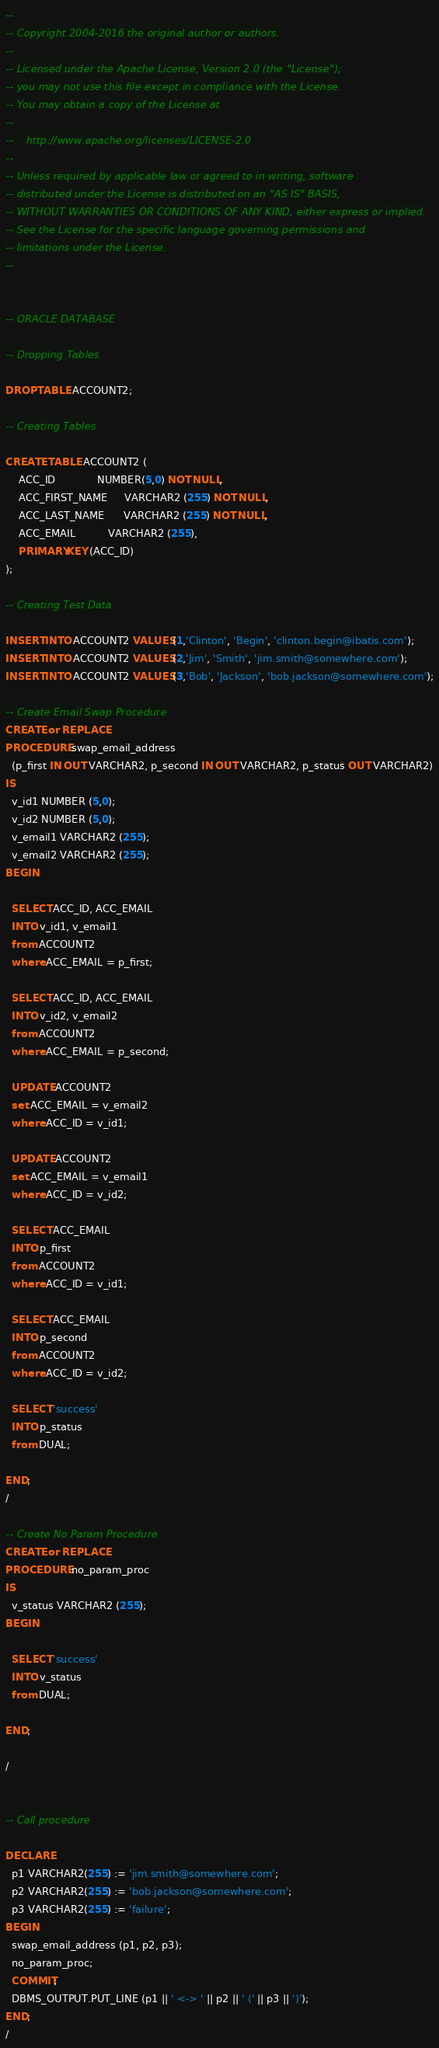<code> <loc_0><loc_0><loc_500><loc_500><_SQL_>--
-- Copyright 2004-2016 the original author or authors.
--
-- Licensed under the Apache License, Version 2.0 (the "License");
-- you may not use this file except in compliance with the License.
-- You may obtain a copy of the License at
--
--    http://www.apache.org/licenses/LICENSE-2.0
--
-- Unless required by applicable law or agreed to in writing, software
-- distributed under the License is distributed on an "AS IS" BASIS,
-- WITHOUT WARRANTIES OR CONDITIONS OF ANY KIND, either express or implied.
-- See the License for the specific language governing permissions and
-- limitations under the License.
--


-- ORACLE DATABASE

-- Dropping Tables

DROP TABLE ACCOUNT2;

-- Creating Tables

CREATE TABLE ACCOUNT2 (
    ACC_ID             NUMBER(5,0) NOT NULL,
    ACC_FIRST_NAME     VARCHAR2 (255) NOT NULL,
    ACC_LAST_NAME      VARCHAR2 (255) NOT NULL,
    ACC_EMAIL          VARCHAR2 (255),
    PRIMARY KEY (ACC_ID)
);

-- Creating Test Data

INSERT INTO ACCOUNT2 VALUES(1,'Clinton', 'Begin', 'clinton.begin@ibatis.com');
INSERT INTO ACCOUNT2 VALUES(2,'Jim', 'Smith', 'jim.smith@somewhere.com');
INSERT INTO ACCOUNT2 VALUES(3,'Bob', 'Jackson', 'bob.jackson@somewhere.com');

-- Create Email Swap Procedure
CREATE or REPLACE
PROCEDURE swap_email_address
  (p_first IN OUT VARCHAR2, p_second IN OUT VARCHAR2, p_status OUT VARCHAR2)
IS
  v_id1 NUMBER (5,0);
  v_id2 NUMBER (5,0);
  v_email1 VARCHAR2 (255);
  v_email2 VARCHAR2 (255);
BEGIN

  SELECT ACC_ID, ACC_EMAIL
  INTO v_id1, v_email1
  from ACCOUNT2
  where ACC_EMAIL = p_first;

  SELECT ACC_ID, ACC_EMAIL
  INTO v_id2, v_email2
  from ACCOUNT2
  where ACC_EMAIL = p_second;

  UPDATE ACCOUNT2
  set ACC_EMAIL = v_email2
  where ACC_ID = v_id1;

  UPDATE ACCOUNT2
  set ACC_EMAIL = v_email1
  where ACC_ID = v_id2;

  SELECT ACC_EMAIL
  INTO p_first
  from ACCOUNT2
  where ACC_ID = v_id1;

  SELECT ACC_EMAIL
  INTO p_second
  from ACCOUNT2
  where ACC_ID = v_id2;

  SELECT 'success'
  INTO p_status
  from DUAL;

END;
/

-- Create No Param Procedure
CREATE or REPLACE
PROCEDURE no_param_proc
IS
  v_status VARCHAR2 (255);
BEGIN

  SELECT 'success'
  INTO v_status
  from DUAL;

END;

/


-- Call procedure

DECLARE
  p1 VARCHAR2(255) := 'jim.smith@somewhere.com';
  p2 VARCHAR2(255) := 'bob.jackson@somewhere.com';
  p3 VARCHAR2(255) := 'failure';
BEGIN
  swap_email_address (p1, p2, p3);
  no_param_proc;
  COMMIT;
  DBMS_OUTPUT.PUT_LINE (p1 || ' <-> ' || p2 || ' (' || p3 || ')');
END;
/

</code> 